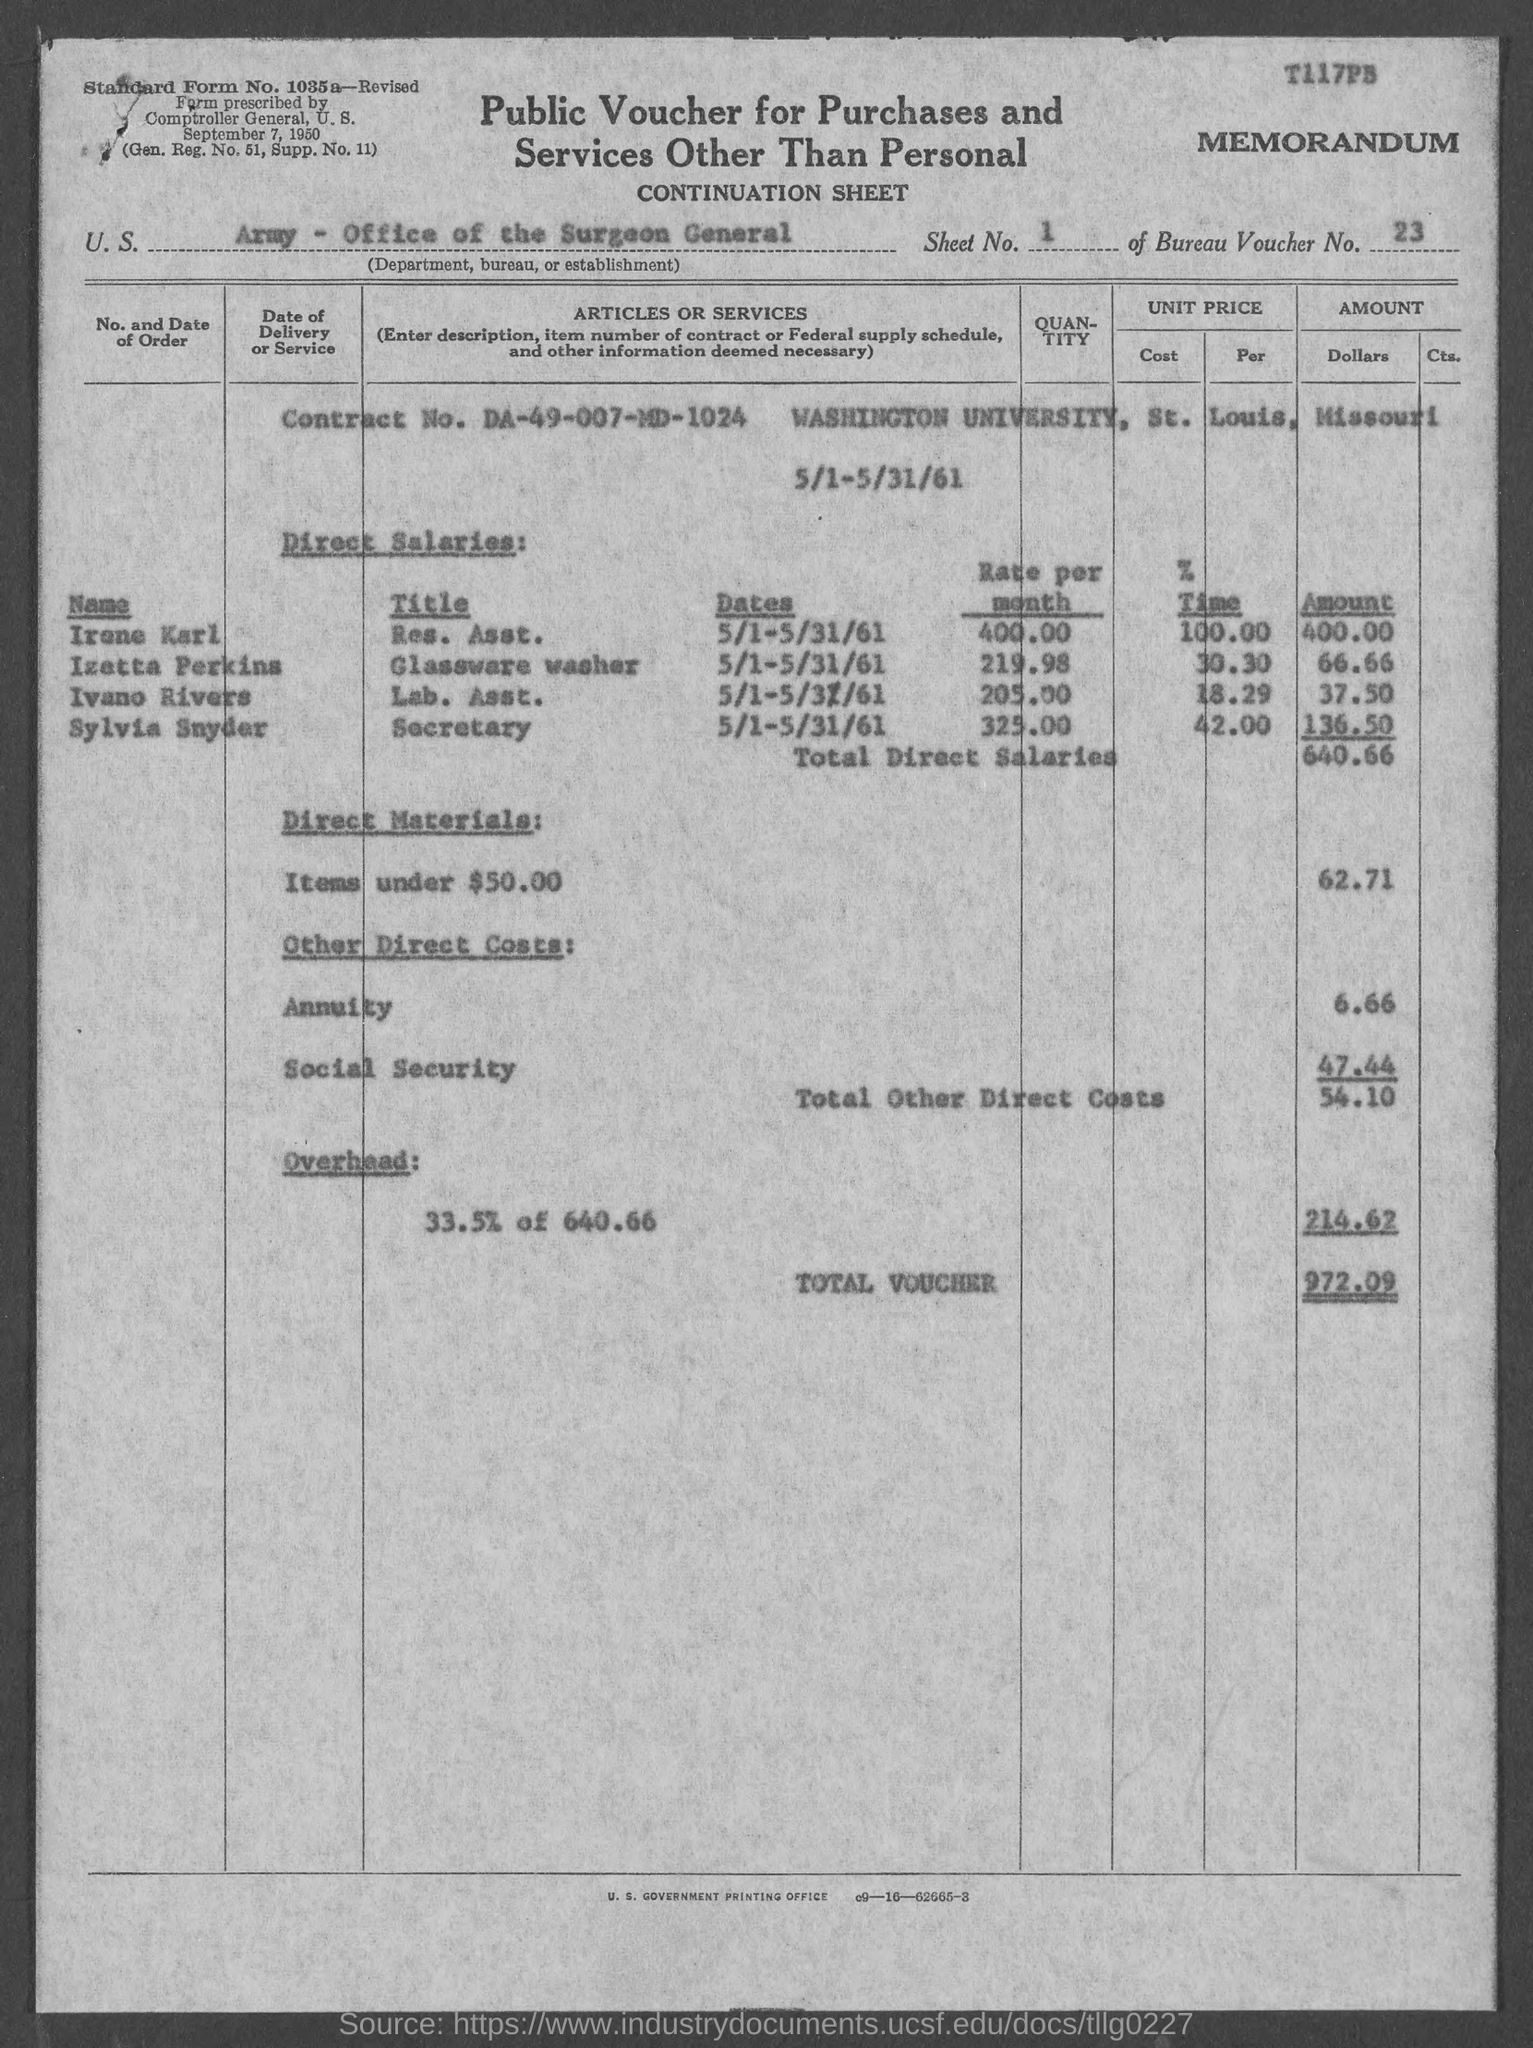Which university is mentioned in this document?
Make the answer very short. Washington University. Where is Washington University located?
Provide a succinct answer. St. Louis, Missouri. What is the Contract No. given?
Give a very brief answer. DA-49-007-MD-1024. What is the amount shown for Total Voucher?
Offer a very short reply. 972.09. What is the amount given for Total Direct Salaries?
Your answer should be very brief. 640.66. What is the Bureau Voucher No.?
Make the answer very short. 23. What is the title of the form as given in the top center of the document?
Give a very brief answer. Public Voucher for Purchases and Services Other Than Personal. 